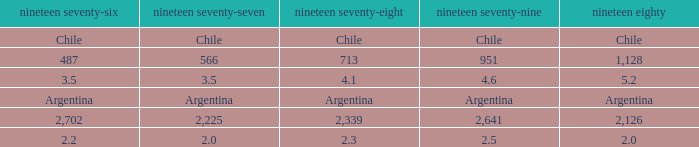What is 1977 when 1978 is 4.1? 3.5. 